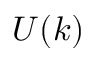<formula> <loc_0><loc_0><loc_500><loc_500>U ( k )</formula> 